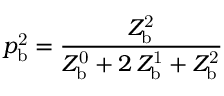Convert formula to latex. <formula><loc_0><loc_0><loc_500><loc_500>p _ { b } ^ { 2 } = \frac { Z _ { b } ^ { 2 } } { Z _ { b } ^ { 0 } + 2 \, Z _ { b } ^ { 1 } + Z _ { b } ^ { 2 } }</formula> 